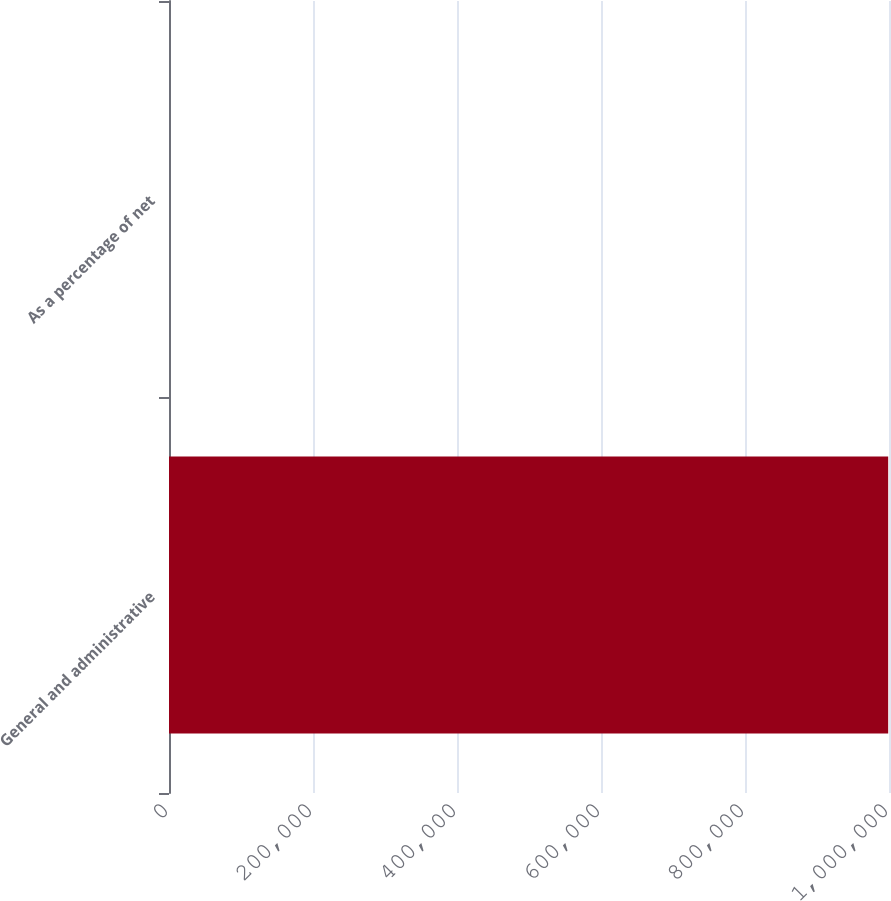Convert chart to OTSL. <chart><loc_0><loc_0><loc_500><loc_500><bar_chart><fcel>General and administrative<fcel>As a percentage of net<nl><fcel>998871<fcel>11.7<nl></chart> 